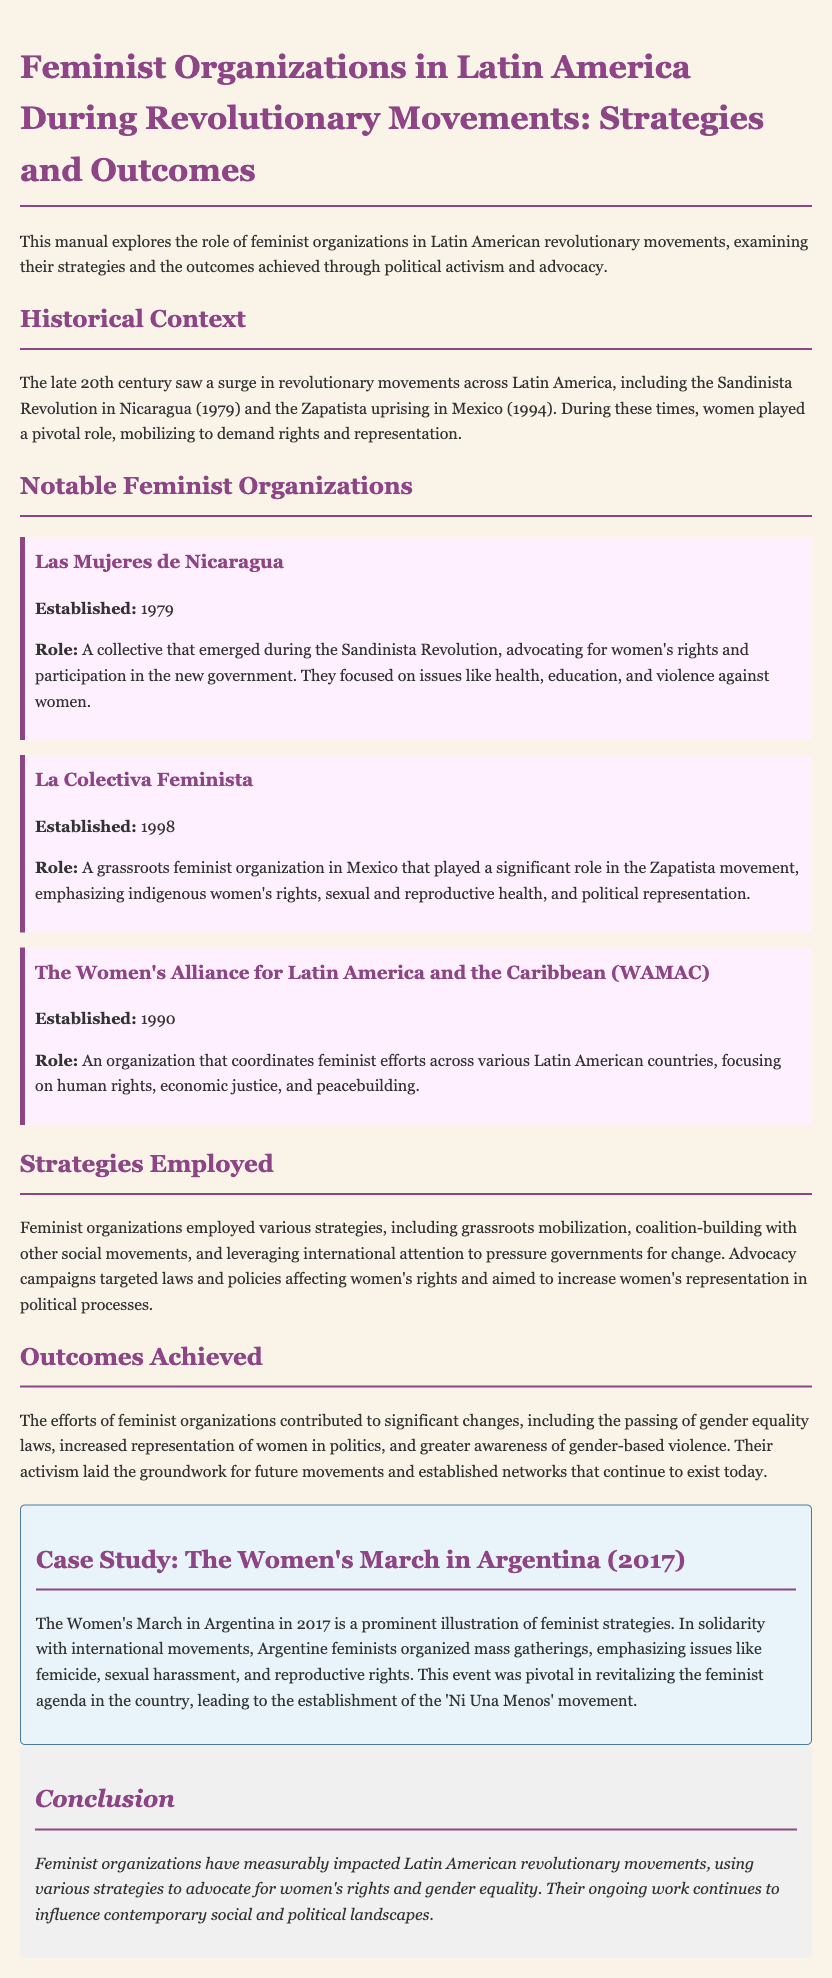What is the title of the document? The title of the document is presented in the header section of the manual, which outlines the main focus of the content.
Answer: Feminist Organizations in Latin America During Revolutionary Movements: Strategies and Outcomes When was Las Mujeres de Nicaragua established? The establishment date of Las Mujeres de Nicaragua is found in the section detailing notable feminist organizations.
Answer: 1979 What issue did Las Mujeres de Nicaragua focus on? The document specifies the focus areas of Las Mujeres de Nicaragua, which highlight their advocacy efforts during the revolutionary period.
Answer: women's rights and participation in the new government Which organization emphasized indigenous women's rights? This information is provided in the description of notable feminist organizations, highlighting their respective focuses.
Answer: La Colectiva Feminista What strategy did feminist organizations employ? Various strategies are discussed in the document, outlining the approaches used by feminist organizations during revolutionary movements.
Answer: grassroots mobilization What significant event took place in Argentina in 2017? The case study section mentions this event as a pivotal moment for feminist activism in Argentina, linking it to broader international movements.
Answer: The Women's March What was the outcome of feminist organizations' efforts? This is outlined in the outcomes section, detailing the impacts of their activism on laws and political representation.
Answer: gender equality laws What does the conclusion summarize? The conclusion summarizes the impact and ongoing influence of feminist organizations in the context of Latin American revolutionary movements.
Answer: Feminist organizations have measurably impacted Latin American revolutionary movements 